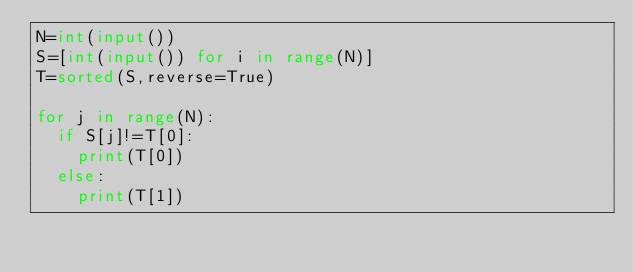<code> <loc_0><loc_0><loc_500><loc_500><_Python_>N=int(input())
S=[int(input()) for i in range(N)]
T=sorted(S,reverse=True)

for j in range(N):
  if S[j]!=T[0]:
    print(T[0])
  else:
    print(T[1])

  
</code> 